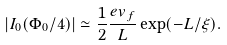Convert formula to latex. <formula><loc_0><loc_0><loc_500><loc_500>| I _ { 0 } ( \Phi _ { 0 } / 4 ) | \simeq \frac { 1 } { 2 } \frac { e v _ { f } } { L } \exp ( - L / \xi ) .</formula> 